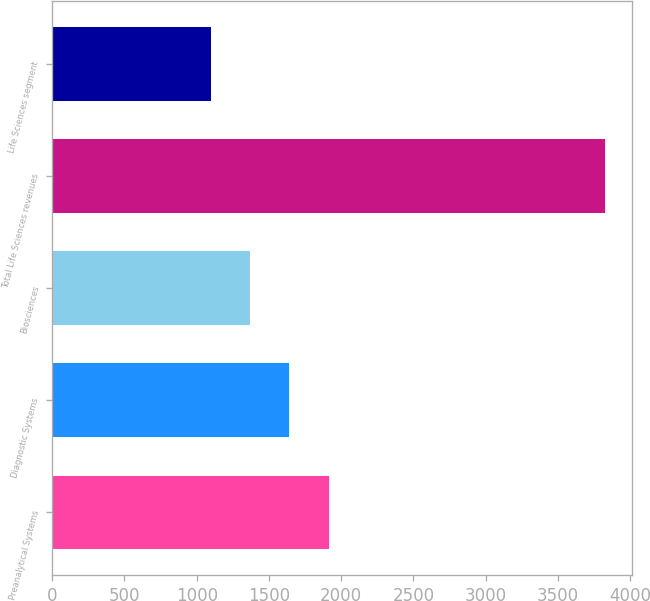<chart> <loc_0><loc_0><loc_500><loc_500><bar_chart><fcel>Preanalytical Systems<fcel>Diagnostic Systems<fcel>Biosciences<fcel>Total Life Sciences revenues<fcel>Life Sciences segment<nl><fcel>1914.5<fcel>1642<fcel>1369.5<fcel>3822<fcel>1097<nl></chart> 